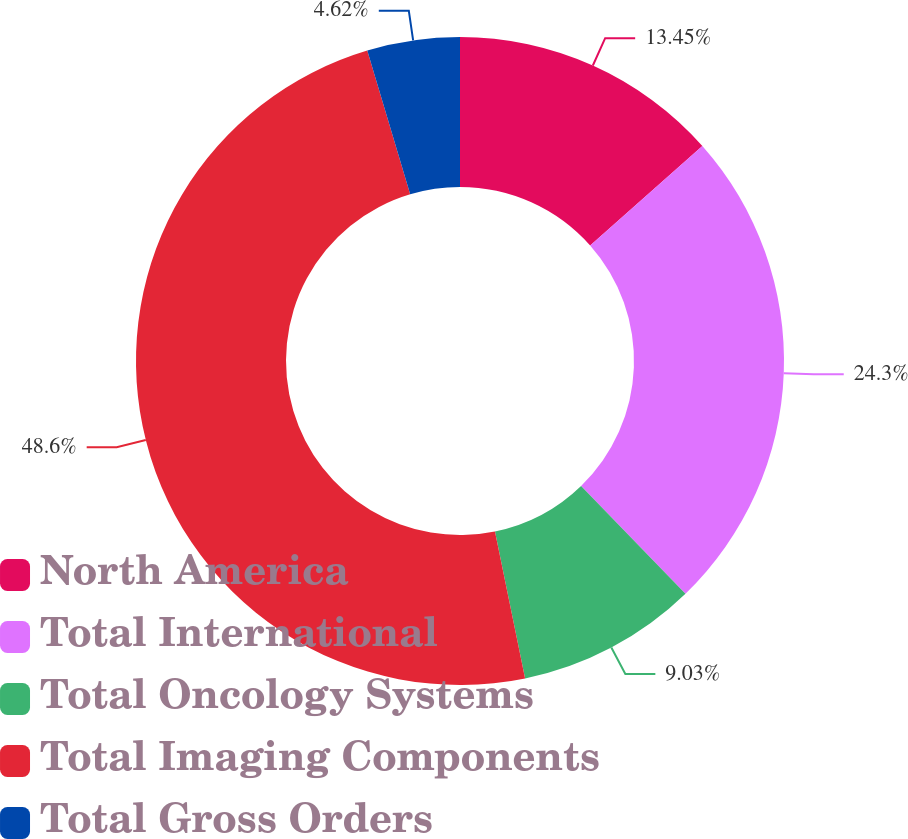Convert chart. <chart><loc_0><loc_0><loc_500><loc_500><pie_chart><fcel>North America<fcel>Total International<fcel>Total Oncology Systems<fcel>Total Imaging Components<fcel>Total Gross Orders<nl><fcel>13.45%<fcel>24.3%<fcel>9.03%<fcel>48.6%<fcel>4.62%<nl></chart> 